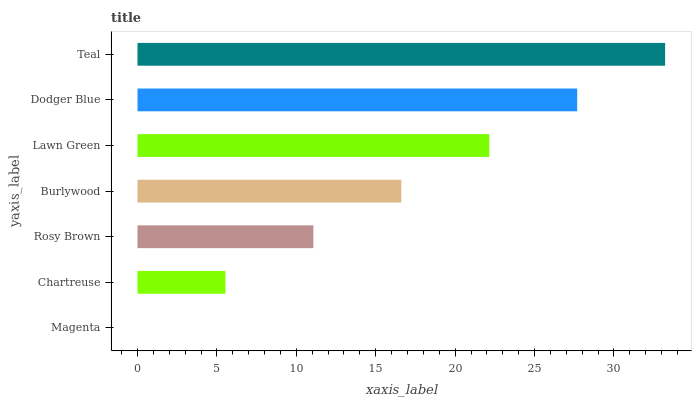Is Magenta the minimum?
Answer yes or no. Yes. Is Teal the maximum?
Answer yes or no. Yes. Is Chartreuse the minimum?
Answer yes or no. No. Is Chartreuse the maximum?
Answer yes or no. No. Is Chartreuse greater than Magenta?
Answer yes or no. Yes. Is Magenta less than Chartreuse?
Answer yes or no. Yes. Is Magenta greater than Chartreuse?
Answer yes or no. No. Is Chartreuse less than Magenta?
Answer yes or no. No. Is Burlywood the high median?
Answer yes or no. Yes. Is Burlywood the low median?
Answer yes or no. Yes. Is Rosy Brown the high median?
Answer yes or no. No. Is Chartreuse the low median?
Answer yes or no. No. 